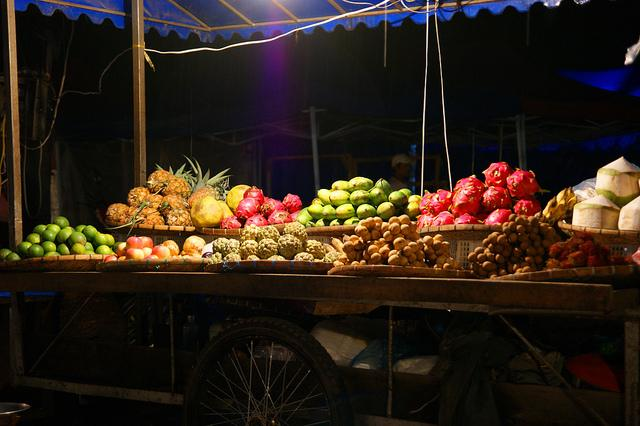What would you call this type of fruit seller? Please explain your reasoning. street vendor. They don't have a building. 